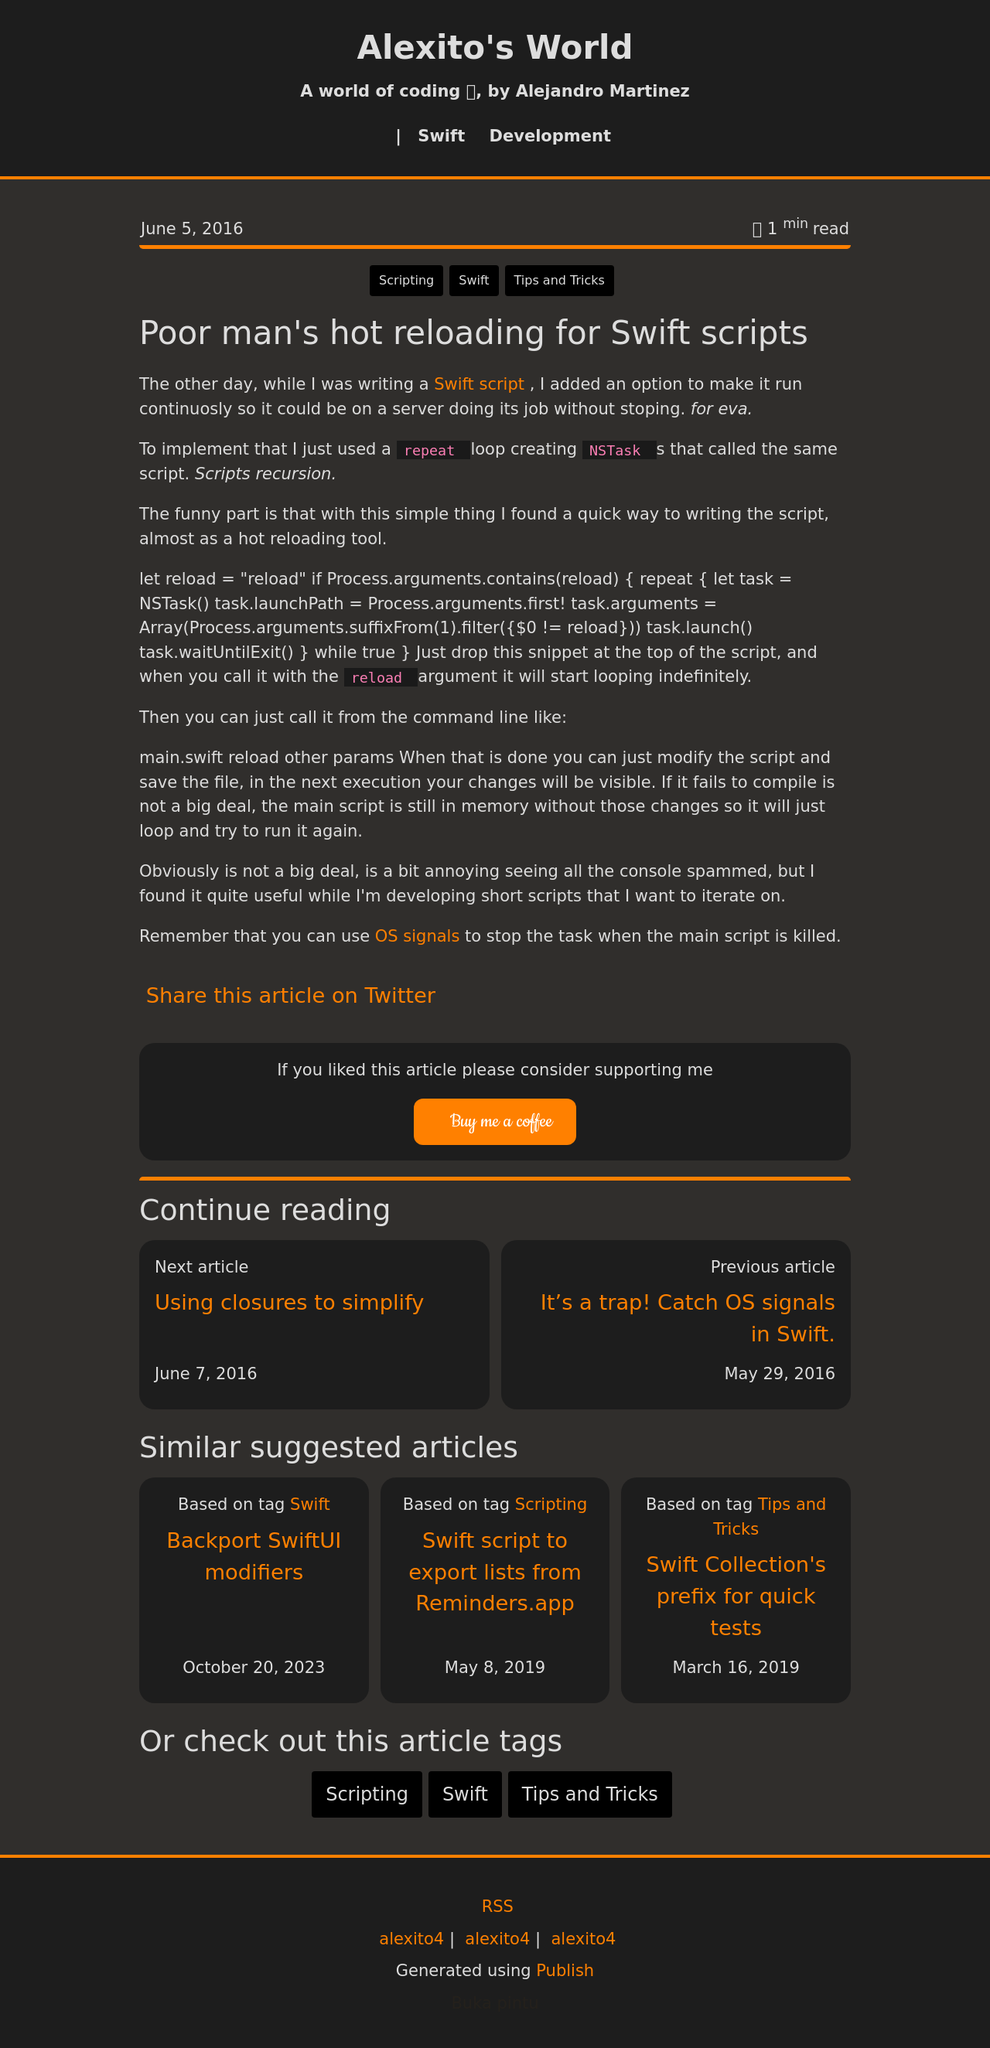What are the key elements visible in the website design shown? The website design prominently features a dark theme with text highlighted in orange. Key elements include a straightforward navigation bar, attention-grabbing headlines, an easily accessible 'Buy me a coffee' button for donations, and clearly defined content sections that enhance readability. Additionally, the footer provides essential links and a unique RSS feed icon. 